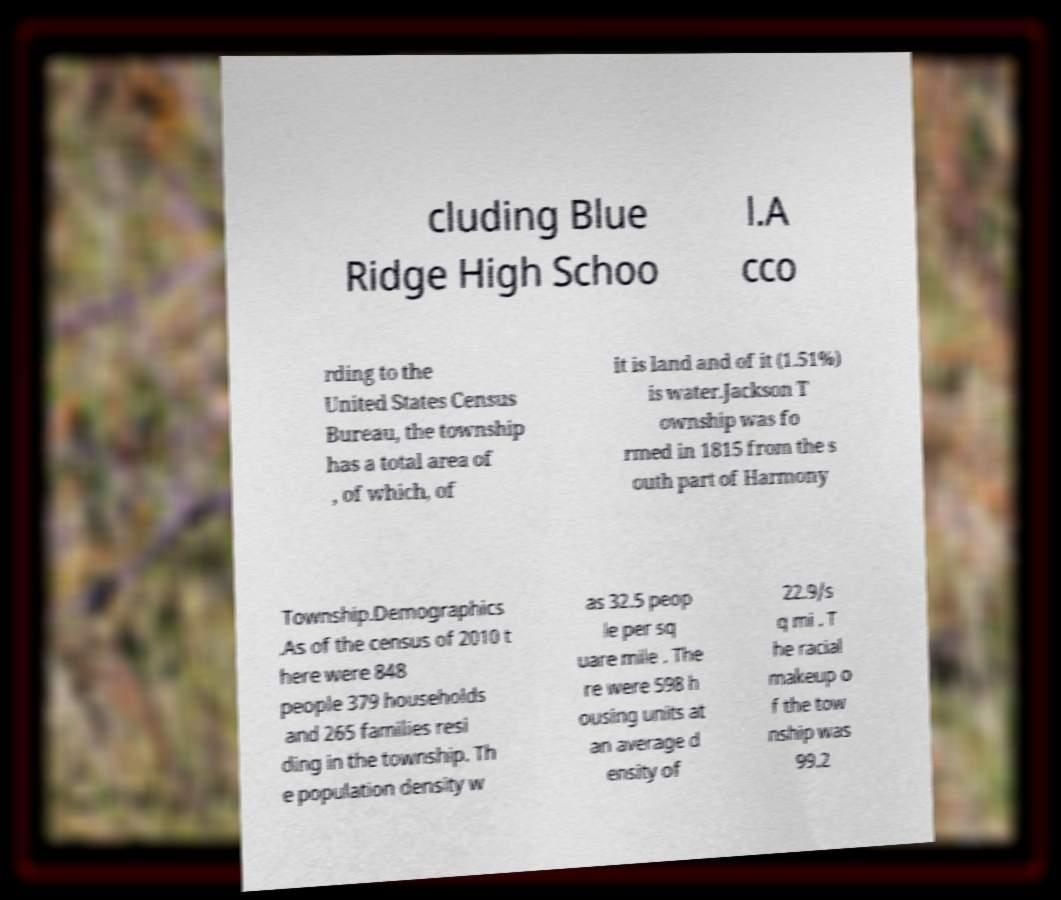Could you assist in decoding the text presented in this image and type it out clearly? cluding Blue Ridge High Schoo l.A cco rding to the United States Census Bureau, the township has a total area of , of which, of it is land and of it (1.51%) is water.Jackson T ownship was fo rmed in 1815 from the s outh part of Harmony Township.Demographics .As of the census of 2010 t here were 848 people 379 households and 265 families resi ding in the township. Th e population density w as 32.5 peop le per sq uare mile . The re were 598 h ousing units at an average d ensity of 22.9/s q mi . T he racial makeup o f the tow nship was 99.2 